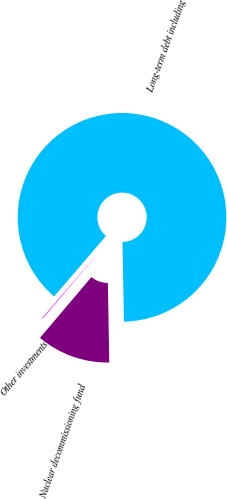Convert chart. <chart><loc_0><loc_0><loc_500><loc_500><pie_chart><fcel>Nuclear decommissioning fund<fcel>Other investments<fcel>Long-term debt including<nl><fcel>11.47%<fcel>0.11%<fcel>88.43%<nl></chart> 